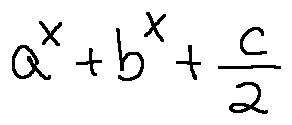Convert formula to latex. <formula><loc_0><loc_0><loc_500><loc_500>a ^ { x } + b ^ { x } + \frac { c } { 2 }</formula> 